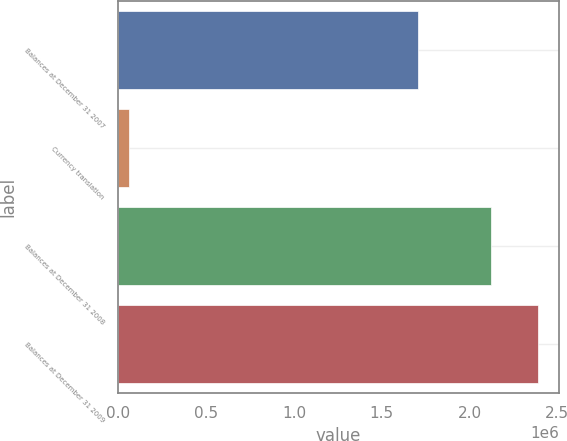Convert chart. <chart><loc_0><loc_0><loc_500><loc_500><bar_chart><fcel>Balances at December 31 2007<fcel>Currency translation<fcel>Balances at December 31 2008<fcel>Balances at December 31 2009<nl><fcel>1.70608e+06<fcel>59797<fcel>2.11885e+06<fcel>2.38843e+06<nl></chart> 